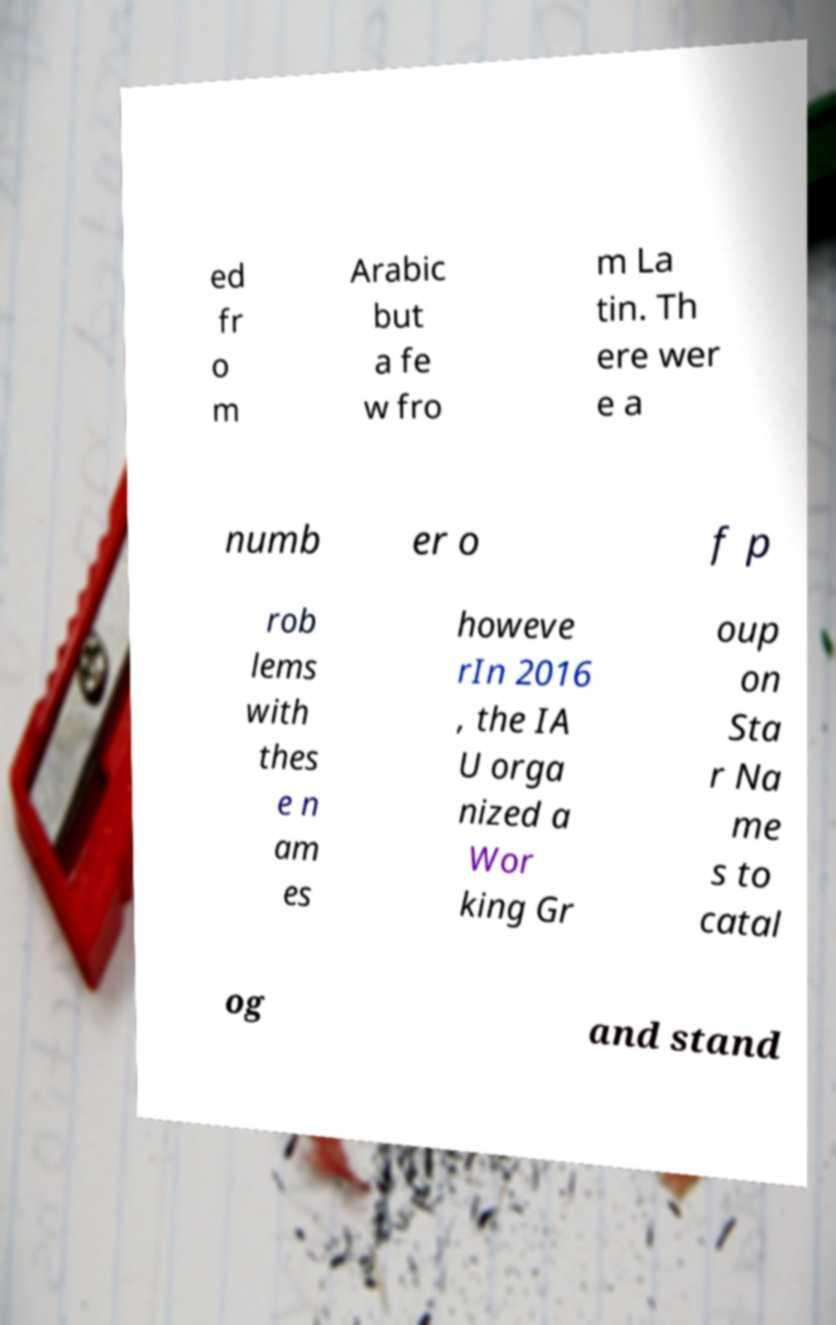Can you read and provide the text displayed in the image?This photo seems to have some interesting text. Can you extract and type it out for me? ed fr o m Arabic but a fe w fro m La tin. Th ere wer e a numb er o f p rob lems with thes e n am es howeve rIn 2016 , the IA U orga nized a Wor king Gr oup on Sta r Na me s to catal og and stand 